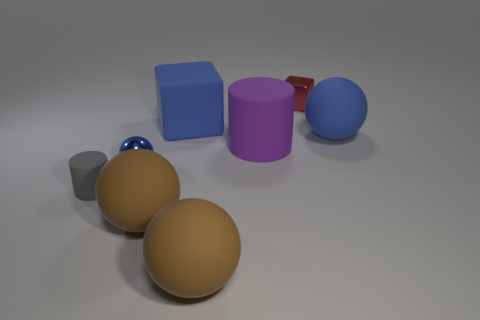Subtract all gray spheres. Subtract all cyan cylinders. How many spheres are left? 4 Add 2 purple matte things. How many objects exist? 10 Subtract all cylinders. How many objects are left? 6 Add 3 small matte cylinders. How many small matte cylinders exist? 4 Subtract 0 gray balls. How many objects are left? 8 Subtract all big blocks. Subtract all blue balls. How many objects are left? 5 Add 6 small things. How many small things are left? 9 